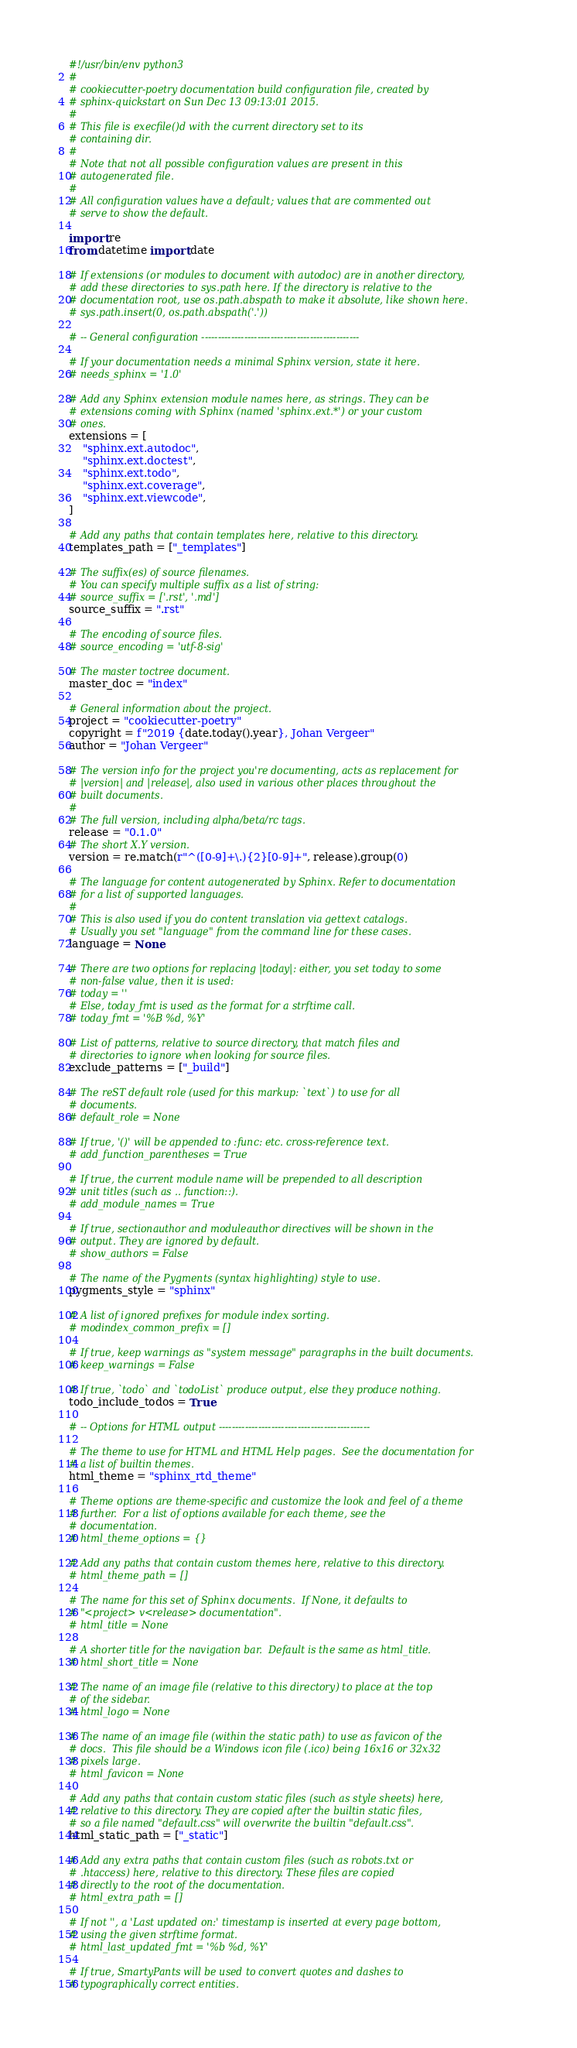Convert code to text. <code><loc_0><loc_0><loc_500><loc_500><_Python_>#!/usr/bin/env python3
#
# cookiecutter-poetry documentation build configuration file, created by
# sphinx-quickstart on Sun Dec 13 09:13:01 2015.
#
# This file is execfile()d with the current directory set to its
# containing dir.
#
# Note that not all possible configuration values are present in this
# autogenerated file.
#
# All configuration values have a default; values that are commented out
# serve to show the default.

import re
from datetime import date

# If extensions (or modules to document with autodoc) are in another directory,
# add these directories to sys.path here. If the directory is relative to the
# documentation root, use os.path.abspath to make it absolute, like shown here.
# sys.path.insert(0, os.path.abspath('.'))

# -- General configuration ------------------------------------------------

# If your documentation needs a minimal Sphinx version, state it here.
# needs_sphinx = '1.0'

# Add any Sphinx extension module names here, as strings. They can be
# extensions coming with Sphinx (named 'sphinx.ext.*') or your custom
# ones.
extensions = [
    "sphinx.ext.autodoc",
    "sphinx.ext.doctest",
    "sphinx.ext.todo",
    "sphinx.ext.coverage",
    "sphinx.ext.viewcode",
]

# Add any paths that contain templates here, relative to this directory.
templates_path = ["_templates"]

# The suffix(es) of source filenames.
# You can specify multiple suffix as a list of string:
# source_suffix = ['.rst', '.md']
source_suffix = ".rst"

# The encoding of source files.
# source_encoding = 'utf-8-sig'

# The master toctree document.
master_doc = "index"

# General information about the project.
project = "cookiecutter-poetry"
copyright = f"2019 {date.today().year}, Johan Vergeer"
author = "Johan Vergeer"

# The version info for the project you're documenting, acts as replacement for
# |version| and |release|, also used in various other places throughout the
# built documents.
#
# The full version, including alpha/beta/rc tags.
release = "0.1.0"
# The short X.Y version.
version = re.match(r"^([0-9]+\.){2}[0-9]+", release).group(0)

# The language for content autogenerated by Sphinx. Refer to documentation
# for a list of supported languages.
#
# This is also used if you do content translation via gettext catalogs.
# Usually you set "language" from the command line for these cases.
language = None

# There are two options for replacing |today|: either, you set today to some
# non-false value, then it is used:
# today = ''
# Else, today_fmt is used as the format for a strftime call.
# today_fmt = '%B %d, %Y'

# List of patterns, relative to source directory, that match files and
# directories to ignore when looking for source files.
exclude_patterns = ["_build"]

# The reST default role (used for this markup: `text`) to use for all
# documents.
# default_role = None

# If true, '()' will be appended to :func: etc. cross-reference text.
# add_function_parentheses = True

# If true, the current module name will be prepended to all description
# unit titles (such as .. function::).
# add_module_names = True

# If true, sectionauthor and moduleauthor directives will be shown in the
# output. They are ignored by default.
# show_authors = False

# The name of the Pygments (syntax highlighting) style to use.
pygments_style = "sphinx"

# A list of ignored prefixes for module index sorting.
# modindex_common_prefix = []

# If true, keep warnings as "system message" paragraphs in the built documents.
# keep_warnings = False

# If true, `todo` and `todoList` produce output, else they produce nothing.
todo_include_todos = True

# -- Options for HTML output ----------------------------------------------

# The theme to use for HTML and HTML Help pages.  See the documentation for
# a list of builtin themes.
html_theme = "sphinx_rtd_theme"

# Theme options are theme-specific and customize the look and feel of a theme
# further.  For a list of options available for each theme, see the
# documentation.
# html_theme_options = {}

# Add any paths that contain custom themes here, relative to this directory.
# html_theme_path = []

# The name for this set of Sphinx documents.  If None, it defaults to
# "<project> v<release> documentation".
# html_title = None

# A shorter title for the navigation bar.  Default is the same as html_title.
# html_short_title = None

# The name of an image file (relative to this directory) to place at the top
# of the sidebar.
# html_logo = None

# The name of an image file (within the static path) to use as favicon of the
# docs.  This file should be a Windows icon file (.ico) being 16x16 or 32x32
# pixels large.
# html_favicon = None

# Add any paths that contain custom static files (such as style sheets) here,
# relative to this directory. They are copied after the builtin static files,
# so a file named "default.css" will overwrite the builtin "default.css".
html_static_path = ["_static"]

# Add any extra paths that contain custom files (such as robots.txt or
# .htaccess) here, relative to this directory. These files are copied
# directly to the root of the documentation.
# html_extra_path = []

# If not '', a 'Last updated on:' timestamp is inserted at every page bottom,
# using the given strftime format.
# html_last_updated_fmt = '%b %d, %Y'

# If true, SmartyPants will be used to convert quotes and dashes to
# typographically correct entities.</code> 